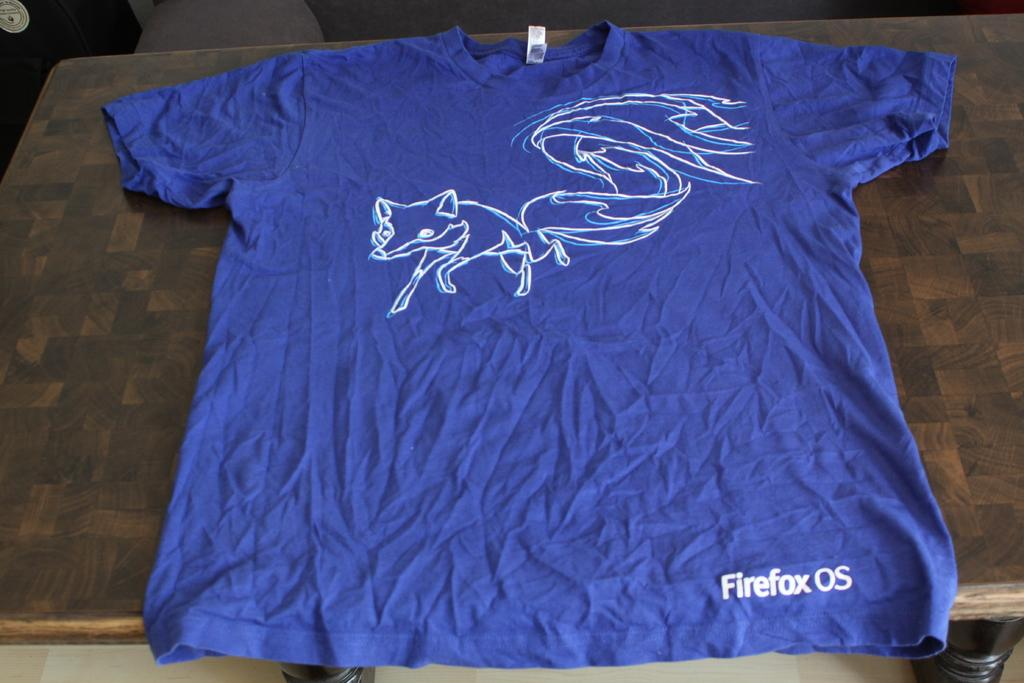<image>
Write a terse but informative summary of the picture. A blue t-shirt with a white outline of a fox has Firefox on the lower left side. 